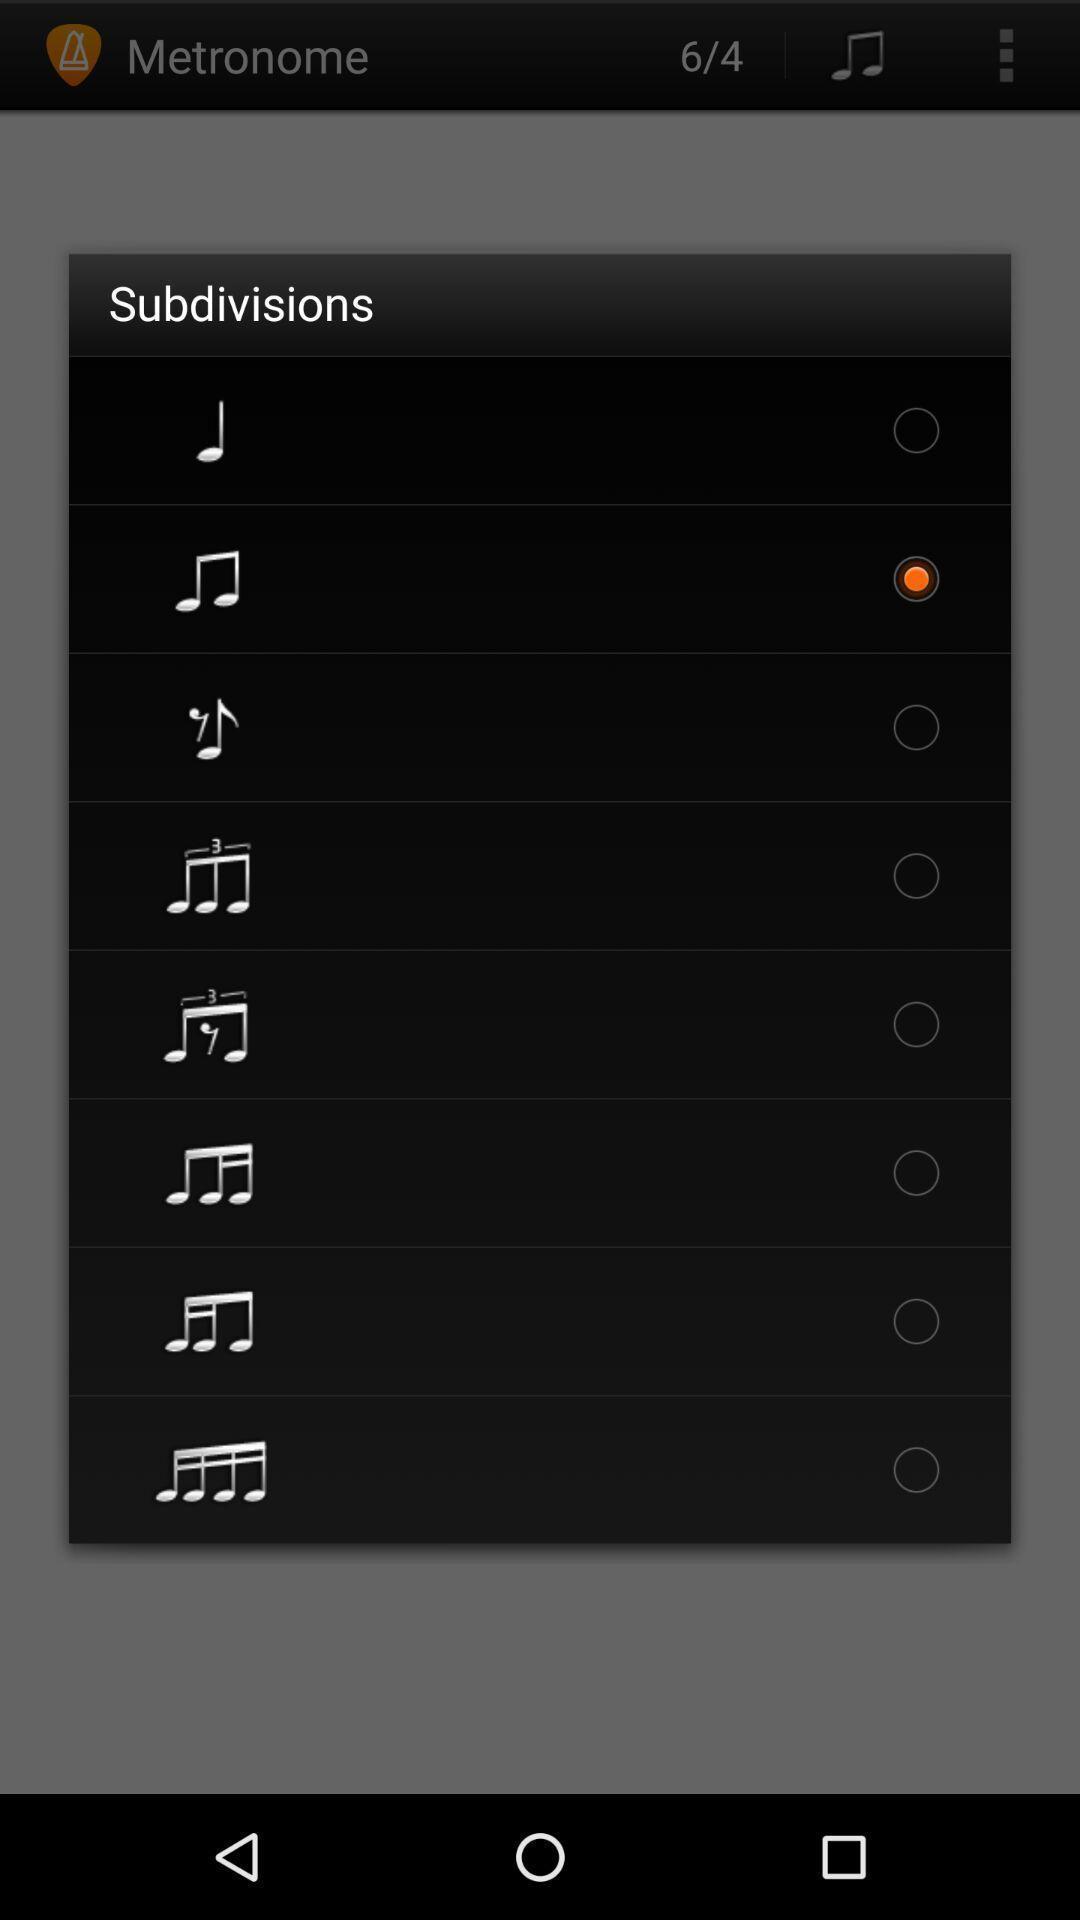Explain what's happening in this screen capture. Pop-up with options of different music notes. 